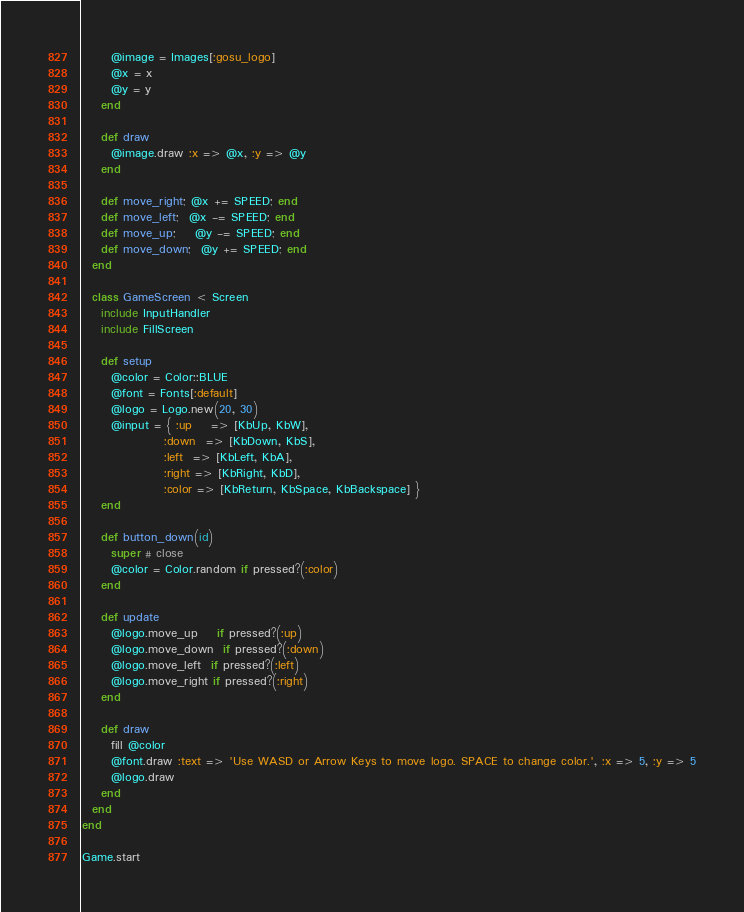<code> <loc_0><loc_0><loc_500><loc_500><_Ruby_>      @image = Images[:gosu_logo]
      @x = x
      @y = y
    end

    def draw
      @image.draw :x => @x, :y => @y
    end

    def move_right; @x += SPEED; end
    def move_left;  @x -= SPEED; end
    def move_up;    @y -= SPEED; end
    def move_down;  @y += SPEED; end
  end

  class GameScreen < Screen
    include InputHandler
    include FillScreen

    def setup
      @color = Color::BLUE
      @font = Fonts[:default]
      @logo = Logo.new(20, 30)
      @input = { :up    => [KbUp, KbW],
                 :down  => [KbDown, KbS],
                 :left  => [KbLeft, KbA],
                 :right => [KbRight, KbD],
                 :color => [KbReturn, KbSpace, KbBackspace] }
    end

    def button_down(id)
      super # close
      @color = Color.random if pressed?(:color)
    end

    def update
      @logo.move_up    if pressed?(:up)
      @logo.move_down  if pressed?(:down)
      @logo.move_left  if pressed?(:left)
      @logo.move_right if pressed?(:right)
    end

    def draw
      fill @color
      @font.draw :text => 'Use WASD or Arrow Keys to move logo. SPACE to change color.', :x => 5, :y => 5
      @logo.draw
    end
  end
end

Game.start
</code> 